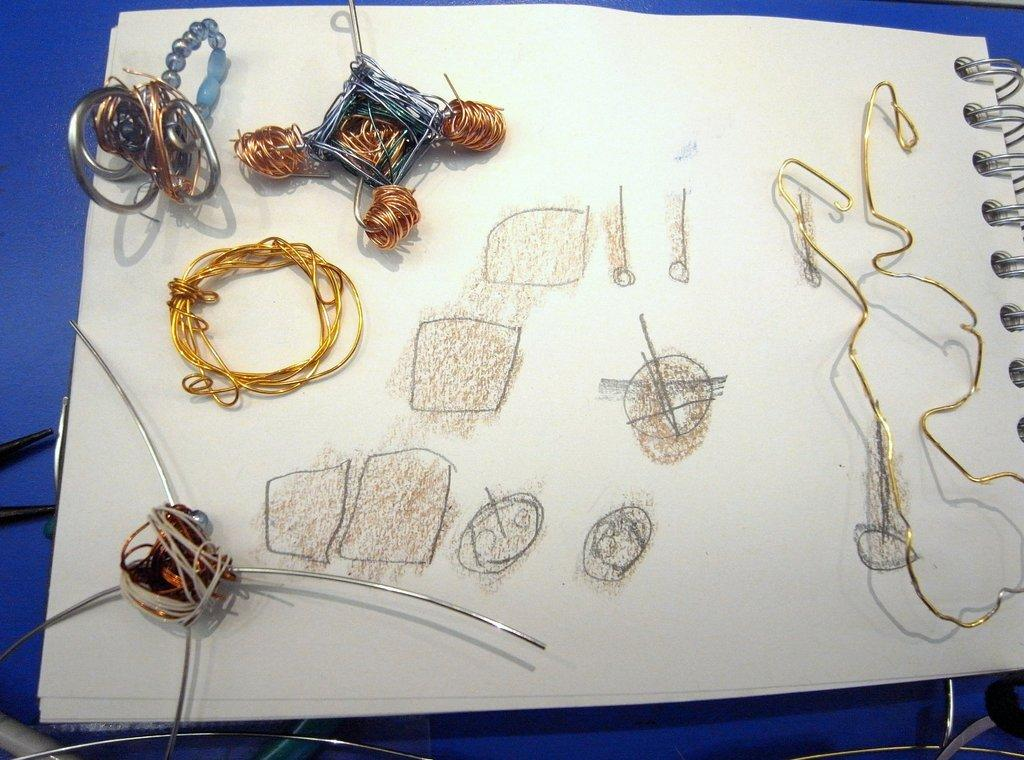What is the main object in the image? There is a notepad in the image. What is placed on the notepad? There are objects placed on the notepad. What can be seen drawn on the notepad? There are shapes drawn on the notepad. How does the notepad contribute to the sleep system in the image? There is no sleep system present in the image, and the notepad is not related to sleep. 